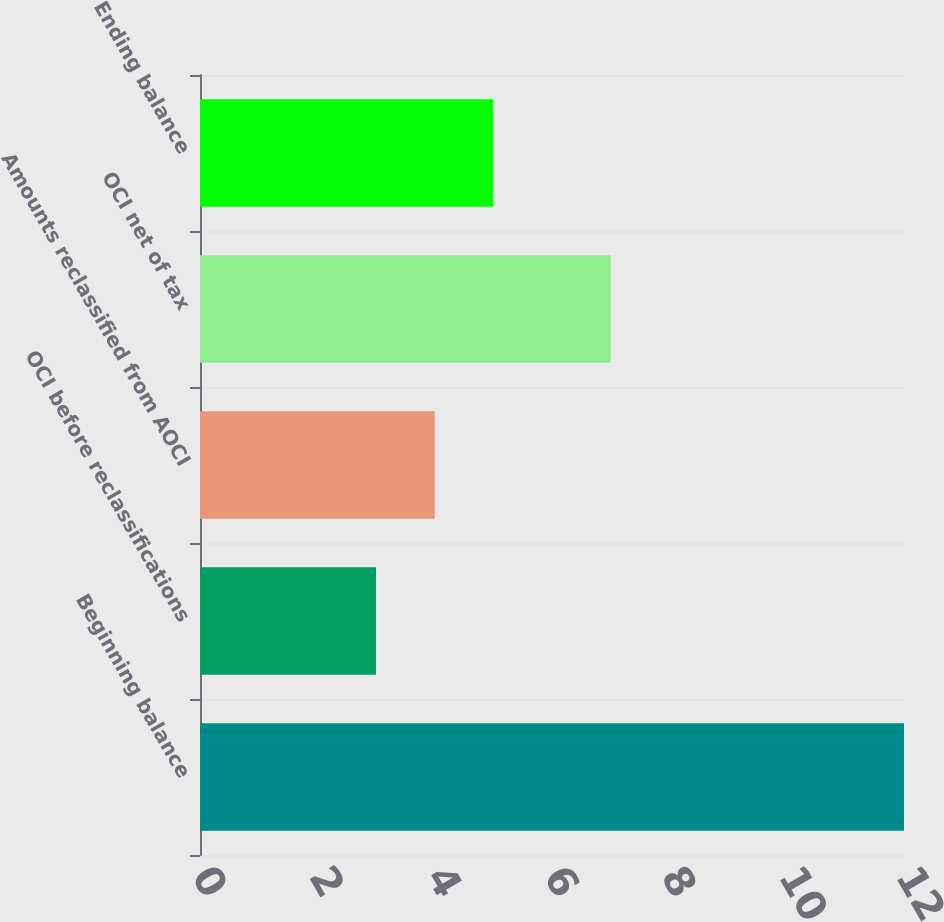Convert chart to OTSL. <chart><loc_0><loc_0><loc_500><loc_500><bar_chart><fcel>Beginning balance<fcel>OCI before reclassifications<fcel>Amounts reclassified from AOCI<fcel>OCI net of tax<fcel>Ending balance<nl><fcel>12<fcel>3<fcel>4<fcel>7<fcel>5<nl></chart> 